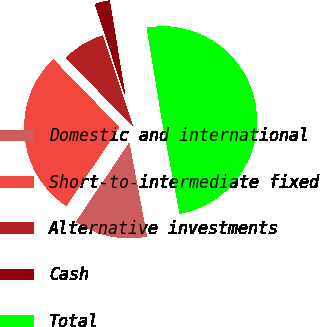<chart> <loc_0><loc_0><loc_500><loc_500><pie_chart><fcel>Domestic and international<fcel>Short-to-intermediate fixed<fcel>Alternative investments<fcel>Cash<fcel>Total<nl><fcel>12.41%<fcel>28.29%<fcel>7.2%<fcel>2.48%<fcel>49.63%<nl></chart> 